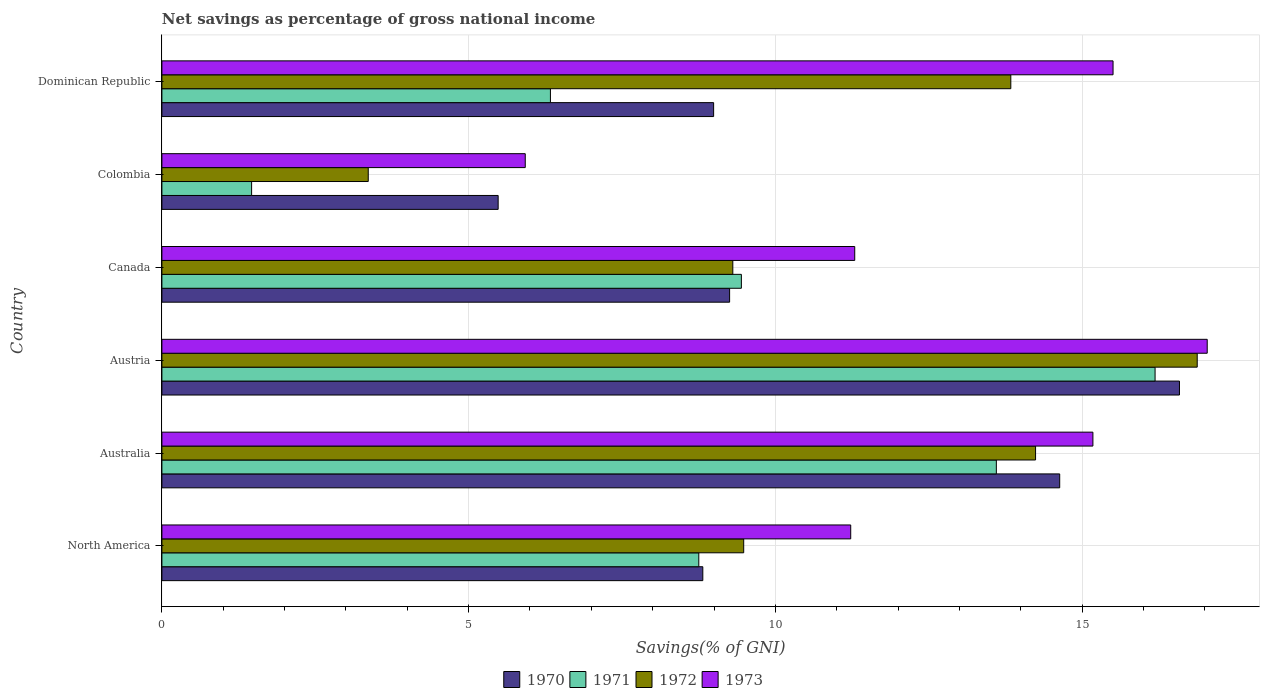Are the number of bars per tick equal to the number of legend labels?
Provide a short and direct response. Yes. How many bars are there on the 2nd tick from the top?
Your response must be concise. 4. What is the label of the 5th group of bars from the top?
Ensure brevity in your answer.  Australia. What is the total savings in 1970 in Dominican Republic?
Your response must be concise. 8.99. Across all countries, what is the maximum total savings in 1973?
Offer a terse response. 17.04. Across all countries, what is the minimum total savings in 1970?
Provide a succinct answer. 5.48. In which country was the total savings in 1972 maximum?
Offer a very short reply. Austria. In which country was the total savings in 1970 minimum?
Give a very brief answer. Colombia. What is the total total savings in 1970 in the graph?
Provide a succinct answer. 63.77. What is the difference between the total savings in 1972 in Colombia and that in Dominican Republic?
Provide a short and direct response. -10.47. What is the difference between the total savings in 1972 in Colombia and the total savings in 1973 in Australia?
Provide a short and direct response. -11.81. What is the average total savings in 1972 per country?
Provide a short and direct response. 11.19. What is the difference between the total savings in 1970 and total savings in 1971 in Austria?
Provide a short and direct response. 0.4. In how many countries, is the total savings in 1971 greater than 11 %?
Provide a succinct answer. 2. What is the ratio of the total savings in 1973 in Australia to that in North America?
Your answer should be very brief. 1.35. What is the difference between the highest and the second highest total savings in 1970?
Keep it short and to the point. 1.95. What is the difference between the highest and the lowest total savings in 1971?
Keep it short and to the point. 14.73. What does the 4th bar from the top in Canada represents?
Your answer should be compact. 1970. What does the 4th bar from the bottom in Canada represents?
Keep it short and to the point. 1973. What is the difference between two consecutive major ticks on the X-axis?
Give a very brief answer. 5. Are the values on the major ticks of X-axis written in scientific E-notation?
Offer a very short reply. No. Does the graph contain grids?
Provide a short and direct response. Yes. How many legend labels are there?
Ensure brevity in your answer.  4. What is the title of the graph?
Ensure brevity in your answer.  Net savings as percentage of gross national income. What is the label or title of the X-axis?
Offer a terse response. Savings(% of GNI). What is the label or title of the Y-axis?
Your answer should be very brief. Country. What is the Savings(% of GNI) of 1970 in North America?
Ensure brevity in your answer.  8.82. What is the Savings(% of GNI) in 1971 in North America?
Keep it short and to the point. 8.75. What is the Savings(% of GNI) in 1972 in North America?
Give a very brief answer. 9.48. What is the Savings(% of GNI) of 1973 in North America?
Keep it short and to the point. 11.23. What is the Savings(% of GNI) of 1970 in Australia?
Offer a very short reply. 14.63. What is the Savings(% of GNI) of 1971 in Australia?
Offer a terse response. 13.6. What is the Savings(% of GNI) of 1972 in Australia?
Make the answer very short. 14.24. What is the Savings(% of GNI) of 1973 in Australia?
Offer a terse response. 15.18. What is the Savings(% of GNI) of 1970 in Austria?
Provide a short and direct response. 16.59. What is the Savings(% of GNI) in 1971 in Austria?
Provide a short and direct response. 16.19. What is the Savings(% of GNI) in 1972 in Austria?
Your response must be concise. 16.88. What is the Savings(% of GNI) of 1973 in Austria?
Ensure brevity in your answer.  17.04. What is the Savings(% of GNI) in 1970 in Canada?
Make the answer very short. 9.25. What is the Savings(% of GNI) of 1971 in Canada?
Your answer should be very brief. 9.45. What is the Savings(% of GNI) in 1972 in Canada?
Offer a terse response. 9.31. What is the Savings(% of GNI) of 1973 in Canada?
Make the answer very short. 11.29. What is the Savings(% of GNI) of 1970 in Colombia?
Give a very brief answer. 5.48. What is the Savings(% of GNI) of 1971 in Colombia?
Provide a succinct answer. 1.46. What is the Savings(% of GNI) in 1972 in Colombia?
Your answer should be compact. 3.36. What is the Savings(% of GNI) of 1973 in Colombia?
Your answer should be very brief. 5.92. What is the Savings(% of GNI) in 1970 in Dominican Republic?
Offer a very short reply. 8.99. What is the Savings(% of GNI) of 1971 in Dominican Republic?
Your answer should be very brief. 6.33. What is the Savings(% of GNI) in 1972 in Dominican Republic?
Provide a short and direct response. 13.84. What is the Savings(% of GNI) in 1973 in Dominican Republic?
Keep it short and to the point. 15.5. Across all countries, what is the maximum Savings(% of GNI) of 1970?
Keep it short and to the point. 16.59. Across all countries, what is the maximum Savings(% of GNI) in 1971?
Your answer should be compact. 16.19. Across all countries, what is the maximum Savings(% of GNI) in 1972?
Your answer should be very brief. 16.88. Across all countries, what is the maximum Savings(% of GNI) of 1973?
Give a very brief answer. 17.04. Across all countries, what is the minimum Savings(% of GNI) of 1970?
Ensure brevity in your answer.  5.48. Across all countries, what is the minimum Savings(% of GNI) in 1971?
Give a very brief answer. 1.46. Across all countries, what is the minimum Savings(% of GNI) in 1972?
Your response must be concise. 3.36. Across all countries, what is the minimum Savings(% of GNI) of 1973?
Give a very brief answer. 5.92. What is the total Savings(% of GNI) in 1970 in the graph?
Provide a short and direct response. 63.77. What is the total Savings(% of GNI) of 1971 in the graph?
Offer a very short reply. 55.79. What is the total Savings(% of GNI) in 1972 in the graph?
Offer a terse response. 67.11. What is the total Savings(% of GNI) in 1973 in the graph?
Your answer should be compact. 76.17. What is the difference between the Savings(% of GNI) of 1970 in North America and that in Australia?
Your response must be concise. -5.82. What is the difference between the Savings(% of GNI) in 1971 in North America and that in Australia?
Keep it short and to the point. -4.85. What is the difference between the Savings(% of GNI) of 1972 in North America and that in Australia?
Give a very brief answer. -4.76. What is the difference between the Savings(% of GNI) in 1973 in North America and that in Australia?
Offer a very short reply. -3.95. What is the difference between the Savings(% of GNI) in 1970 in North America and that in Austria?
Make the answer very short. -7.77. What is the difference between the Savings(% of GNI) of 1971 in North America and that in Austria?
Your answer should be very brief. -7.44. What is the difference between the Savings(% of GNI) in 1972 in North America and that in Austria?
Keep it short and to the point. -7.39. What is the difference between the Savings(% of GNI) in 1973 in North America and that in Austria?
Ensure brevity in your answer.  -5.81. What is the difference between the Savings(% of GNI) of 1970 in North America and that in Canada?
Provide a succinct answer. -0.44. What is the difference between the Savings(% of GNI) in 1971 in North America and that in Canada?
Your answer should be compact. -0.69. What is the difference between the Savings(% of GNI) of 1972 in North America and that in Canada?
Give a very brief answer. 0.18. What is the difference between the Savings(% of GNI) of 1973 in North America and that in Canada?
Offer a terse response. -0.07. What is the difference between the Savings(% of GNI) in 1970 in North America and that in Colombia?
Provide a succinct answer. 3.34. What is the difference between the Savings(% of GNI) in 1971 in North America and that in Colombia?
Provide a succinct answer. 7.29. What is the difference between the Savings(% of GNI) in 1972 in North America and that in Colombia?
Provide a short and direct response. 6.12. What is the difference between the Savings(% of GNI) in 1973 in North America and that in Colombia?
Make the answer very short. 5.31. What is the difference between the Savings(% of GNI) in 1970 in North America and that in Dominican Republic?
Your answer should be compact. -0.18. What is the difference between the Savings(% of GNI) in 1971 in North America and that in Dominican Republic?
Your answer should be compact. 2.42. What is the difference between the Savings(% of GNI) of 1972 in North America and that in Dominican Republic?
Provide a succinct answer. -4.35. What is the difference between the Savings(% of GNI) in 1973 in North America and that in Dominican Republic?
Make the answer very short. -4.28. What is the difference between the Savings(% of GNI) of 1970 in Australia and that in Austria?
Your answer should be compact. -1.95. What is the difference between the Savings(% of GNI) of 1971 in Australia and that in Austria?
Provide a succinct answer. -2.59. What is the difference between the Savings(% of GNI) of 1972 in Australia and that in Austria?
Provide a short and direct response. -2.64. What is the difference between the Savings(% of GNI) in 1973 in Australia and that in Austria?
Your answer should be compact. -1.86. What is the difference between the Savings(% of GNI) in 1970 in Australia and that in Canada?
Make the answer very short. 5.38. What is the difference between the Savings(% of GNI) of 1971 in Australia and that in Canada?
Give a very brief answer. 4.16. What is the difference between the Savings(% of GNI) of 1972 in Australia and that in Canada?
Make the answer very short. 4.93. What is the difference between the Savings(% of GNI) of 1973 in Australia and that in Canada?
Offer a very short reply. 3.88. What is the difference between the Savings(% of GNI) in 1970 in Australia and that in Colombia?
Ensure brevity in your answer.  9.15. What is the difference between the Savings(% of GNI) of 1971 in Australia and that in Colombia?
Make the answer very short. 12.14. What is the difference between the Savings(% of GNI) in 1972 in Australia and that in Colombia?
Offer a terse response. 10.88. What is the difference between the Savings(% of GNI) in 1973 in Australia and that in Colombia?
Provide a short and direct response. 9.25. What is the difference between the Savings(% of GNI) of 1970 in Australia and that in Dominican Republic?
Make the answer very short. 5.64. What is the difference between the Savings(% of GNI) in 1971 in Australia and that in Dominican Republic?
Provide a succinct answer. 7.27. What is the difference between the Savings(% of GNI) of 1972 in Australia and that in Dominican Republic?
Give a very brief answer. 0.4. What is the difference between the Savings(% of GNI) of 1973 in Australia and that in Dominican Republic?
Offer a terse response. -0.33. What is the difference between the Savings(% of GNI) of 1970 in Austria and that in Canada?
Provide a succinct answer. 7.33. What is the difference between the Savings(% of GNI) in 1971 in Austria and that in Canada?
Give a very brief answer. 6.74. What is the difference between the Savings(% of GNI) in 1972 in Austria and that in Canada?
Give a very brief answer. 7.57. What is the difference between the Savings(% of GNI) in 1973 in Austria and that in Canada?
Your response must be concise. 5.75. What is the difference between the Savings(% of GNI) in 1970 in Austria and that in Colombia?
Keep it short and to the point. 11.11. What is the difference between the Savings(% of GNI) in 1971 in Austria and that in Colombia?
Ensure brevity in your answer.  14.73. What is the difference between the Savings(% of GNI) of 1972 in Austria and that in Colombia?
Ensure brevity in your answer.  13.51. What is the difference between the Savings(% of GNI) in 1973 in Austria and that in Colombia?
Offer a terse response. 11.12. What is the difference between the Savings(% of GNI) in 1970 in Austria and that in Dominican Republic?
Provide a succinct answer. 7.59. What is the difference between the Savings(% of GNI) of 1971 in Austria and that in Dominican Republic?
Offer a terse response. 9.86. What is the difference between the Savings(% of GNI) of 1972 in Austria and that in Dominican Republic?
Your response must be concise. 3.04. What is the difference between the Savings(% of GNI) of 1973 in Austria and that in Dominican Republic?
Provide a succinct answer. 1.54. What is the difference between the Savings(% of GNI) in 1970 in Canada and that in Colombia?
Keep it short and to the point. 3.77. What is the difference between the Savings(% of GNI) in 1971 in Canada and that in Colombia?
Offer a very short reply. 7.98. What is the difference between the Savings(% of GNI) of 1972 in Canada and that in Colombia?
Offer a very short reply. 5.94. What is the difference between the Savings(% of GNI) in 1973 in Canada and that in Colombia?
Keep it short and to the point. 5.37. What is the difference between the Savings(% of GNI) of 1970 in Canada and that in Dominican Republic?
Ensure brevity in your answer.  0.26. What is the difference between the Savings(% of GNI) in 1971 in Canada and that in Dominican Republic?
Make the answer very short. 3.11. What is the difference between the Savings(% of GNI) in 1972 in Canada and that in Dominican Republic?
Keep it short and to the point. -4.53. What is the difference between the Savings(% of GNI) of 1973 in Canada and that in Dominican Republic?
Keep it short and to the point. -4.21. What is the difference between the Savings(% of GNI) in 1970 in Colombia and that in Dominican Republic?
Your answer should be very brief. -3.51. What is the difference between the Savings(% of GNI) in 1971 in Colombia and that in Dominican Republic?
Provide a short and direct response. -4.87. What is the difference between the Savings(% of GNI) in 1972 in Colombia and that in Dominican Republic?
Offer a terse response. -10.47. What is the difference between the Savings(% of GNI) of 1973 in Colombia and that in Dominican Republic?
Provide a short and direct response. -9.58. What is the difference between the Savings(% of GNI) of 1970 in North America and the Savings(% of GNI) of 1971 in Australia?
Your response must be concise. -4.78. What is the difference between the Savings(% of GNI) in 1970 in North America and the Savings(% of GNI) in 1972 in Australia?
Keep it short and to the point. -5.42. What is the difference between the Savings(% of GNI) of 1970 in North America and the Savings(% of GNI) of 1973 in Australia?
Offer a terse response. -6.36. What is the difference between the Savings(% of GNI) in 1971 in North America and the Savings(% of GNI) in 1972 in Australia?
Make the answer very short. -5.49. What is the difference between the Savings(% of GNI) in 1971 in North America and the Savings(% of GNI) in 1973 in Australia?
Keep it short and to the point. -6.42. What is the difference between the Savings(% of GNI) of 1972 in North America and the Savings(% of GNI) of 1973 in Australia?
Ensure brevity in your answer.  -5.69. What is the difference between the Savings(% of GNI) of 1970 in North America and the Savings(% of GNI) of 1971 in Austria?
Give a very brief answer. -7.37. What is the difference between the Savings(% of GNI) of 1970 in North America and the Savings(% of GNI) of 1972 in Austria?
Keep it short and to the point. -8.06. What is the difference between the Savings(% of GNI) in 1970 in North America and the Savings(% of GNI) in 1973 in Austria?
Offer a terse response. -8.22. What is the difference between the Savings(% of GNI) of 1971 in North America and the Savings(% of GNI) of 1972 in Austria?
Keep it short and to the point. -8.12. What is the difference between the Savings(% of GNI) of 1971 in North America and the Savings(% of GNI) of 1973 in Austria?
Keep it short and to the point. -8.29. What is the difference between the Savings(% of GNI) of 1972 in North America and the Savings(% of GNI) of 1973 in Austria?
Offer a very short reply. -7.56. What is the difference between the Savings(% of GNI) of 1970 in North America and the Savings(% of GNI) of 1971 in Canada?
Your response must be concise. -0.63. What is the difference between the Savings(% of GNI) in 1970 in North America and the Savings(% of GNI) in 1972 in Canada?
Offer a very short reply. -0.49. What is the difference between the Savings(% of GNI) of 1970 in North America and the Savings(% of GNI) of 1973 in Canada?
Provide a succinct answer. -2.48. What is the difference between the Savings(% of GNI) in 1971 in North America and the Savings(% of GNI) in 1972 in Canada?
Keep it short and to the point. -0.55. What is the difference between the Savings(% of GNI) of 1971 in North America and the Savings(% of GNI) of 1973 in Canada?
Give a very brief answer. -2.54. What is the difference between the Savings(% of GNI) in 1972 in North America and the Savings(% of GNI) in 1973 in Canada?
Ensure brevity in your answer.  -1.81. What is the difference between the Savings(% of GNI) in 1970 in North America and the Savings(% of GNI) in 1971 in Colombia?
Provide a succinct answer. 7.36. What is the difference between the Savings(% of GNI) in 1970 in North America and the Savings(% of GNI) in 1972 in Colombia?
Keep it short and to the point. 5.45. What is the difference between the Savings(% of GNI) in 1970 in North America and the Savings(% of GNI) in 1973 in Colombia?
Make the answer very short. 2.89. What is the difference between the Savings(% of GNI) of 1971 in North America and the Savings(% of GNI) of 1972 in Colombia?
Provide a short and direct response. 5.39. What is the difference between the Savings(% of GNI) of 1971 in North America and the Savings(% of GNI) of 1973 in Colombia?
Keep it short and to the point. 2.83. What is the difference between the Savings(% of GNI) in 1972 in North America and the Savings(% of GNI) in 1973 in Colombia?
Your response must be concise. 3.56. What is the difference between the Savings(% of GNI) of 1970 in North America and the Savings(% of GNI) of 1971 in Dominican Republic?
Ensure brevity in your answer.  2.48. What is the difference between the Savings(% of GNI) in 1970 in North America and the Savings(% of GNI) in 1972 in Dominican Republic?
Offer a very short reply. -5.02. What is the difference between the Savings(% of GNI) in 1970 in North America and the Savings(% of GNI) in 1973 in Dominican Republic?
Your answer should be compact. -6.69. What is the difference between the Savings(% of GNI) in 1971 in North America and the Savings(% of GNI) in 1972 in Dominican Republic?
Provide a short and direct response. -5.09. What is the difference between the Savings(% of GNI) of 1971 in North America and the Savings(% of GNI) of 1973 in Dominican Republic?
Offer a terse response. -6.75. What is the difference between the Savings(% of GNI) in 1972 in North America and the Savings(% of GNI) in 1973 in Dominican Republic?
Your answer should be very brief. -6.02. What is the difference between the Savings(% of GNI) of 1970 in Australia and the Savings(% of GNI) of 1971 in Austria?
Your response must be concise. -1.55. What is the difference between the Savings(% of GNI) of 1970 in Australia and the Savings(% of GNI) of 1972 in Austria?
Offer a very short reply. -2.24. What is the difference between the Savings(% of GNI) in 1970 in Australia and the Savings(% of GNI) in 1973 in Austria?
Keep it short and to the point. -2.4. What is the difference between the Savings(% of GNI) in 1971 in Australia and the Savings(% of GNI) in 1972 in Austria?
Offer a terse response. -3.27. What is the difference between the Savings(% of GNI) in 1971 in Australia and the Savings(% of GNI) in 1973 in Austria?
Your answer should be very brief. -3.44. What is the difference between the Savings(% of GNI) in 1972 in Australia and the Savings(% of GNI) in 1973 in Austria?
Your response must be concise. -2.8. What is the difference between the Savings(% of GNI) of 1970 in Australia and the Savings(% of GNI) of 1971 in Canada?
Make the answer very short. 5.19. What is the difference between the Savings(% of GNI) in 1970 in Australia and the Savings(% of GNI) in 1972 in Canada?
Keep it short and to the point. 5.33. What is the difference between the Savings(% of GNI) of 1970 in Australia and the Savings(% of GNI) of 1973 in Canada?
Your answer should be compact. 3.34. What is the difference between the Savings(% of GNI) of 1971 in Australia and the Savings(% of GNI) of 1972 in Canada?
Give a very brief answer. 4.3. What is the difference between the Savings(% of GNI) in 1971 in Australia and the Savings(% of GNI) in 1973 in Canada?
Offer a terse response. 2.31. What is the difference between the Savings(% of GNI) of 1972 in Australia and the Savings(% of GNI) of 1973 in Canada?
Offer a terse response. 2.95. What is the difference between the Savings(% of GNI) in 1970 in Australia and the Savings(% of GNI) in 1971 in Colombia?
Provide a short and direct response. 13.17. What is the difference between the Savings(% of GNI) of 1970 in Australia and the Savings(% of GNI) of 1972 in Colombia?
Offer a terse response. 11.27. What is the difference between the Savings(% of GNI) in 1970 in Australia and the Savings(% of GNI) in 1973 in Colombia?
Make the answer very short. 8.71. What is the difference between the Savings(% of GNI) of 1971 in Australia and the Savings(% of GNI) of 1972 in Colombia?
Your response must be concise. 10.24. What is the difference between the Savings(% of GNI) of 1971 in Australia and the Savings(% of GNI) of 1973 in Colombia?
Provide a short and direct response. 7.68. What is the difference between the Savings(% of GNI) of 1972 in Australia and the Savings(% of GNI) of 1973 in Colombia?
Ensure brevity in your answer.  8.32. What is the difference between the Savings(% of GNI) of 1970 in Australia and the Savings(% of GNI) of 1971 in Dominican Republic?
Provide a succinct answer. 8.3. What is the difference between the Savings(% of GNI) in 1970 in Australia and the Savings(% of GNI) in 1972 in Dominican Republic?
Your response must be concise. 0.8. What is the difference between the Savings(% of GNI) in 1970 in Australia and the Savings(% of GNI) in 1973 in Dominican Republic?
Your answer should be very brief. -0.87. What is the difference between the Savings(% of GNI) in 1971 in Australia and the Savings(% of GNI) in 1972 in Dominican Republic?
Provide a succinct answer. -0.24. What is the difference between the Savings(% of GNI) of 1971 in Australia and the Savings(% of GNI) of 1973 in Dominican Republic?
Offer a terse response. -1.9. What is the difference between the Savings(% of GNI) of 1972 in Australia and the Savings(% of GNI) of 1973 in Dominican Republic?
Your answer should be compact. -1.26. What is the difference between the Savings(% of GNI) in 1970 in Austria and the Savings(% of GNI) in 1971 in Canada?
Your response must be concise. 7.14. What is the difference between the Savings(% of GNI) of 1970 in Austria and the Savings(% of GNI) of 1972 in Canada?
Your response must be concise. 7.28. What is the difference between the Savings(% of GNI) of 1970 in Austria and the Savings(% of GNI) of 1973 in Canada?
Make the answer very short. 5.29. What is the difference between the Savings(% of GNI) of 1971 in Austria and the Savings(% of GNI) of 1972 in Canada?
Your response must be concise. 6.88. What is the difference between the Savings(% of GNI) in 1971 in Austria and the Savings(% of GNI) in 1973 in Canada?
Make the answer very short. 4.9. What is the difference between the Savings(% of GNI) in 1972 in Austria and the Savings(% of GNI) in 1973 in Canada?
Keep it short and to the point. 5.58. What is the difference between the Savings(% of GNI) in 1970 in Austria and the Savings(% of GNI) in 1971 in Colombia?
Offer a terse response. 15.12. What is the difference between the Savings(% of GNI) of 1970 in Austria and the Savings(% of GNI) of 1972 in Colombia?
Provide a short and direct response. 13.22. What is the difference between the Savings(% of GNI) in 1970 in Austria and the Savings(% of GNI) in 1973 in Colombia?
Provide a succinct answer. 10.66. What is the difference between the Savings(% of GNI) in 1971 in Austria and the Savings(% of GNI) in 1972 in Colombia?
Your answer should be compact. 12.83. What is the difference between the Savings(% of GNI) of 1971 in Austria and the Savings(% of GNI) of 1973 in Colombia?
Ensure brevity in your answer.  10.27. What is the difference between the Savings(% of GNI) in 1972 in Austria and the Savings(% of GNI) in 1973 in Colombia?
Offer a terse response. 10.95. What is the difference between the Savings(% of GNI) in 1970 in Austria and the Savings(% of GNI) in 1971 in Dominican Republic?
Your answer should be very brief. 10.25. What is the difference between the Savings(% of GNI) of 1970 in Austria and the Savings(% of GNI) of 1972 in Dominican Republic?
Ensure brevity in your answer.  2.75. What is the difference between the Savings(% of GNI) in 1970 in Austria and the Savings(% of GNI) in 1973 in Dominican Republic?
Provide a succinct answer. 1.08. What is the difference between the Savings(% of GNI) of 1971 in Austria and the Savings(% of GNI) of 1972 in Dominican Republic?
Ensure brevity in your answer.  2.35. What is the difference between the Savings(% of GNI) in 1971 in Austria and the Savings(% of GNI) in 1973 in Dominican Republic?
Offer a very short reply. 0.69. What is the difference between the Savings(% of GNI) of 1972 in Austria and the Savings(% of GNI) of 1973 in Dominican Republic?
Ensure brevity in your answer.  1.37. What is the difference between the Savings(% of GNI) of 1970 in Canada and the Savings(% of GNI) of 1971 in Colombia?
Offer a very short reply. 7.79. What is the difference between the Savings(% of GNI) in 1970 in Canada and the Savings(% of GNI) in 1972 in Colombia?
Your answer should be compact. 5.89. What is the difference between the Savings(% of GNI) in 1970 in Canada and the Savings(% of GNI) in 1973 in Colombia?
Your response must be concise. 3.33. What is the difference between the Savings(% of GNI) in 1971 in Canada and the Savings(% of GNI) in 1972 in Colombia?
Make the answer very short. 6.08. What is the difference between the Savings(% of GNI) of 1971 in Canada and the Savings(% of GNI) of 1973 in Colombia?
Ensure brevity in your answer.  3.52. What is the difference between the Savings(% of GNI) in 1972 in Canada and the Savings(% of GNI) in 1973 in Colombia?
Your response must be concise. 3.38. What is the difference between the Savings(% of GNI) of 1970 in Canada and the Savings(% of GNI) of 1971 in Dominican Republic?
Keep it short and to the point. 2.92. What is the difference between the Savings(% of GNI) in 1970 in Canada and the Savings(% of GNI) in 1972 in Dominican Republic?
Keep it short and to the point. -4.58. What is the difference between the Savings(% of GNI) in 1970 in Canada and the Savings(% of GNI) in 1973 in Dominican Republic?
Offer a terse response. -6.25. What is the difference between the Savings(% of GNI) of 1971 in Canada and the Savings(% of GNI) of 1972 in Dominican Republic?
Offer a very short reply. -4.39. What is the difference between the Savings(% of GNI) of 1971 in Canada and the Savings(% of GNI) of 1973 in Dominican Republic?
Offer a very short reply. -6.06. What is the difference between the Savings(% of GNI) of 1972 in Canada and the Savings(% of GNI) of 1973 in Dominican Republic?
Offer a terse response. -6.2. What is the difference between the Savings(% of GNI) in 1970 in Colombia and the Savings(% of GNI) in 1971 in Dominican Republic?
Your answer should be compact. -0.85. What is the difference between the Savings(% of GNI) of 1970 in Colombia and the Savings(% of GNI) of 1972 in Dominican Republic?
Your answer should be compact. -8.36. What is the difference between the Savings(% of GNI) of 1970 in Colombia and the Savings(% of GNI) of 1973 in Dominican Republic?
Your answer should be compact. -10.02. What is the difference between the Savings(% of GNI) of 1971 in Colombia and the Savings(% of GNI) of 1972 in Dominican Republic?
Your answer should be compact. -12.38. What is the difference between the Savings(% of GNI) of 1971 in Colombia and the Savings(% of GNI) of 1973 in Dominican Republic?
Your answer should be compact. -14.04. What is the difference between the Savings(% of GNI) in 1972 in Colombia and the Savings(% of GNI) in 1973 in Dominican Republic?
Provide a short and direct response. -12.14. What is the average Savings(% of GNI) of 1970 per country?
Ensure brevity in your answer.  10.63. What is the average Savings(% of GNI) of 1971 per country?
Keep it short and to the point. 9.3. What is the average Savings(% of GNI) in 1972 per country?
Make the answer very short. 11.19. What is the average Savings(% of GNI) of 1973 per country?
Give a very brief answer. 12.69. What is the difference between the Savings(% of GNI) of 1970 and Savings(% of GNI) of 1971 in North America?
Your answer should be very brief. 0.07. What is the difference between the Savings(% of GNI) of 1970 and Savings(% of GNI) of 1972 in North America?
Ensure brevity in your answer.  -0.67. What is the difference between the Savings(% of GNI) in 1970 and Savings(% of GNI) in 1973 in North America?
Provide a succinct answer. -2.41. What is the difference between the Savings(% of GNI) of 1971 and Savings(% of GNI) of 1972 in North America?
Your answer should be compact. -0.73. What is the difference between the Savings(% of GNI) in 1971 and Savings(% of GNI) in 1973 in North America?
Your answer should be very brief. -2.48. What is the difference between the Savings(% of GNI) of 1972 and Savings(% of GNI) of 1973 in North America?
Your response must be concise. -1.74. What is the difference between the Savings(% of GNI) in 1970 and Savings(% of GNI) in 1971 in Australia?
Ensure brevity in your answer.  1.03. What is the difference between the Savings(% of GNI) in 1970 and Savings(% of GNI) in 1972 in Australia?
Offer a very short reply. 0.39. What is the difference between the Savings(% of GNI) in 1970 and Savings(% of GNI) in 1973 in Australia?
Provide a succinct answer. -0.54. What is the difference between the Savings(% of GNI) in 1971 and Savings(% of GNI) in 1972 in Australia?
Offer a terse response. -0.64. What is the difference between the Savings(% of GNI) in 1971 and Savings(% of GNI) in 1973 in Australia?
Offer a very short reply. -1.57. What is the difference between the Savings(% of GNI) of 1972 and Savings(% of GNI) of 1973 in Australia?
Your response must be concise. -0.93. What is the difference between the Savings(% of GNI) in 1970 and Savings(% of GNI) in 1971 in Austria?
Offer a terse response. 0.4. What is the difference between the Savings(% of GNI) in 1970 and Savings(% of GNI) in 1972 in Austria?
Offer a terse response. -0.29. What is the difference between the Savings(% of GNI) of 1970 and Savings(% of GNI) of 1973 in Austria?
Provide a short and direct response. -0.45. What is the difference between the Savings(% of GNI) in 1971 and Savings(% of GNI) in 1972 in Austria?
Your answer should be compact. -0.69. What is the difference between the Savings(% of GNI) of 1971 and Savings(% of GNI) of 1973 in Austria?
Keep it short and to the point. -0.85. What is the difference between the Savings(% of GNI) of 1972 and Savings(% of GNI) of 1973 in Austria?
Your response must be concise. -0.16. What is the difference between the Savings(% of GNI) in 1970 and Savings(% of GNI) in 1971 in Canada?
Offer a very short reply. -0.19. What is the difference between the Savings(% of GNI) of 1970 and Savings(% of GNI) of 1972 in Canada?
Offer a terse response. -0.05. What is the difference between the Savings(% of GNI) of 1970 and Savings(% of GNI) of 1973 in Canada?
Ensure brevity in your answer.  -2.04. What is the difference between the Savings(% of GNI) in 1971 and Savings(% of GNI) in 1972 in Canada?
Keep it short and to the point. 0.14. What is the difference between the Savings(% of GNI) in 1971 and Savings(% of GNI) in 1973 in Canada?
Keep it short and to the point. -1.85. What is the difference between the Savings(% of GNI) in 1972 and Savings(% of GNI) in 1973 in Canada?
Make the answer very short. -1.99. What is the difference between the Savings(% of GNI) in 1970 and Savings(% of GNI) in 1971 in Colombia?
Your answer should be compact. 4.02. What is the difference between the Savings(% of GNI) of 1970 and Savings(% of GNI) of 1972 in Colombia?
Give a very brief answer. 2.12. What is the difference between the Savings(% of GNI) of 1970 and Savings(% of GNI) of 1973 in Colombia?
Your response must be concise. -0.44. What is the difference between the Savings(% of GNI) of 1971 and Savings(% of GNI) of 1972 in Colombia?
Provide a succinct answer. -1.9. What is the difference between the Savings(% of GNI) in 1971 and Savings(% of GNI) in 1973 in Colombia?
Your answer should be very brief. -4.46. What is the difference between the Savings(% of GNI) in 1972 and Savings(% of GNI) in 1973 in Colombia?
Your answer should be compact. -2.56. What is the difference between the Savings(% of GNI) in 1970 and Savings(% of GNI) in 1971 in Dominican Republic?
Keep it short and to the point. 2.66. What is the difference between the Savings(% of GNI) in 1970 and Savings(% of GNI) in 1972 in Dominican Republic?
Your response must be concise. -4.84. What is the difference between the Savings(% of GNI) of 1970 and Savings(% of GNI) of 1973 in Dominican Republic?
Provide a short and direct response. -6.51. What is the difference between the Savings(% of GNI) of 1971 and Savings(% of GNI) of 1972 in Dominican Republic?
Your answer should be very brief. -7.5. What is the difference between the Savings(% of GNI) in 1971 and Savings(% of GNI) in 1973 in Dominican Republic?
Your answer should be compact. -9.17. What is the difference between the Savings(% of GNI) in 1972 and Savings(% of GNI) in 1973 in Dominican Republic?
Offer a very short reply. -1.67. What is the ratio of the Savings(% of GNI) of 1970 in North America to that in Australia?
Your answer should be very brief. 0.6. What is the ratio of the Savings(% of GNI) of 1971 in North America to that in Australia?
Provide a short and direct response. 0.64. What is the ratio of the Savings(% of GNI) of 1972 in North America to that in Australia?
Give a very brief answer. 0.67. What is the ratio of the Savings(% of GNI) in 1973 in North America to that in Australia?
Your answer should be compact. 0.74. What is the ratio of the Savings(% of GNI) of 1970 in North America to that in Austria?
Keep it short and to the point. 0.53. What is the ratio of the Savings(% of GNI) of 1971 in North America to that in Austria?
Provide a short and direct response. 0.54. What is the ratio of the Savings(% of GNI) of 1972 in North America to that in Austria?
Offer a terse response. 0.56. What is the ratio of the Savings(% of GNI) of 1973 in North America to that in Austria?
Provide a short and direct response. 0.66. What is the ratio of the Savings(% of GNI) in 1970 in North America to that in Canada?
Keep it short and to the point. 0.95. What is the ratio of the Savings(% of GNI) in 1971 in North America to that in Canada?
Your answer should be very brief. 0.93. What is the ratio of the Savings(% of GNI) of 1972 in North America to that in Canada?
Your answer should be very brief. 1.02. What is the ratio of the Savings(% of GNI) of 1973 in North America to that in Canada?
Offer a terse response. 0.99. What is the ratio of the Savings(% of GNI) of 1970 in North America to that in Colombia?
Offer a very short reply. 1.61. What is the ratio of the Savings(% of GNI) of 1971 in North America to that in Colombia?
Offer a very short reply. 5.98. What is the ratio of the Savings(% of GNI) in 1972 in North America to that in Colombia?
Make the answer very short. 2.82. What is the ratio of the Savings(% of GNI) of 1973 in North America to that in Colombia?
Keep it short and to the point. 1.9. What is the ratio of the Savings(% of GNI) of 1970 in North America to that in Dominican Republic?
Provide a short and direct response. 0.98. What is the ratio of the Savings(% of GNI) in 1971 in North America to that in Dominican Republic?
Provide a succinct answer. 1.38. What is the ratio of the Savings(% of GNI) in 1972 in North America to that in Dominican Republic?
Keep it short and to the point. 0.69. What is the ratio of the Savings(% of GNI) of 1973 in North America to that in Dominican Republic?
Your answer should be compact. 0.72. What is the ratio of the Savings(% of GNI) in 1970 in Australia to that in Austria?
Provide a short and direct response. 0.88. What is the ratio of the Savings(% of GNI) in 1971 in Australia to that in Austria?
Ensure brevity in your answer.  0.84. What is the ratio of the Savings(% of GNI) of 1972 in Australia to that in Austria?
Your answer should be compact. 0.84. What is the ratio of the Savings(% of GNI) in 1973 in Australia to that in Austria?
Give a very brief answer. 0.89. What is the ratio of the Savings(% of GNI) in 1970 in Australia to that in Canada?
Ensure brevity in your answer.  1.58. What is the ratio of the Savings(% of GNI) of 1971 in Australia to that in Canada?
Provide a succinct answer. 1.44. What is the ratio of the Savings(% of GNI) of 1972 in Australia to that in Canada?
Your answer should be very brief. 1.53. What is the ratio of the Savings(% of GNI) in 1973 in Australia to that in Canada?
Ensure brevity in your answer.  1.34. What is the ratio of the Savings(% of GNI) of 1970 in Australia to that in Colombia?
Give a very brief answer. 2.67. What is the ratio of the Savings(% of GNI) in 1971 in Australia to that in Colombia?
Your answer should be compact. 9.3. What is the ratio of the Savings(% of GNI) of 1972 in Australia to that in Colombia?
Make the answer very short. 4.23. What is the ratio of the Savings(% of GNI) in 1973 in Australia to that in Colombia?
Your response must be concise. 2.56. What is the ratio of the Savings(% of GNI) of 1970 in Australia to that in Dominican Republic?
Give a very brief answer. 1.63. What is the ratio of the Savings(% of GNI) in 1971 in Australia to that in Dominican Republic?
Your answer should be very brief. 2.15. What is the ratio of the Savings(% of GNI) in 1972 in Australia to that in Dominican Republic?
Make the answer very short. 1.03. What is the ratio of the Savings(% of GNI) of 1973 in Australia to that in Dominican Republic?
Provide a succinct answer. 0.98. What is the ratio of the Savings(% of GNI) of 1970 in Austria to that in Canada?
Keep it short and to the point. 1.79. What is the ratio of the Savings(% of GNI) of 1971 in Austria to that in Canada?
Your response must be concise. 1.71. What is the ratio of the Savings(% of GNI) in 1972 in Austria to that in Canada?
Your response must be concise. 1.81. What is the ratio of the Savings(% of GNI) in 1973 in Austria to that in Canada?
Offer a very short reply. 1.51. What is the ratio of the Savings(% of GNI) in 1970 in Austria to that in Colombia?
Give a very brief answer. 3.03. What is the ratio of the Savings(% of GNI) of 1971 in Austria to that in Colombia?
Give a very brief answer. 11.07. What is the ratio of the Savings(% of GNI) of 1972 in Austria to that in Colombia?
Keep it short and to the point. 5.02. What is the ratio of the Savings(% of GNI) in 1973 in Austria to that in Colombia?
Give a very brief answer. 2.88. What is the ratio of the Savings(% of GNI) of 1970 in Austria to that in Dominican Republic?
Ensure brevity in your answer.  1.84. What is the ratio of the Savings(% of GNI) in 1971 in Austria to that in Dominican Republic?
Provide a short and direct response. 2.56. What is the ratio of the Savings(% of GNI) of 1972 in Austria to that in Dominican Republic?
Your answer should be compact. 1.22. What is the ratio of the Savings(% of GNI) of 1973 in Austria to that in Dominican Republic?
Your answer should be compact. 1.1. What is the ratio of the Savings(% of GNI) in 1970 in Canada to that in Colombia?
Give a very brief answer. 1.69. What is the ratio of the Savings(% of GNI) in 1971 in Canada to that in Colombia?
Make the answer very short. 6.46. What is the ratio of the Savings(% of GNI) in 1972 in Canada to that in Colombia?
Provide a succinct answer. 2.77. What is the ratio of the Savings(% of GNI) in 1973 in Canada to that in Colombia?
Your answer should be compact. 1.91. What is the ratio of the Savings(% of GNI) in 1971 in Canada to that in Dominican Republic?
Provide a succinct answer. 1.49. What is the ratio of the Savings(% of GNI) of 1972 in Canada to that in Dominican Republic?
Offer a very short reply. 0.67. What is the ratio of the Savings(% of GNI) in 1973 in Canada to that in Dominican Republic?
Give a very brief answer. 0.73. What is the ratio of the Savings(% of GNI) in 1970 in Colombia to that in Dominican Republic?
Provide a short and direct response. 0.61. What is the ratio of the Savings(% of GNI) in 1971 in Colombia to that in Dominican Republic?
Offer a very short reply. 0.23. What is the ratio of the Savings(% of GNI) of 1972 in Colombia to that in Dominican Republic?
Your response must be concise. 0.24. What is the ratio of the Savings(% of GNI) in 1973 in Colombia to that in Dominican Republic?
Your response must be concise. 0.38. What is the difference between the highest and the second highest Savings(% of GNI) of 1970?
Provide a succinct answer. 1.95. What is the difference between the highest and the second highest Savings(% of GNI) of 1971?
Your response must be concise. 2.59. What is the difference between the highest and the second highest Savings(% of GNI) in 1972?
Provide a short and direct response. 2.64. What is the difference between the highest and the second highest Savings(% of GNI) in 1973?
Offer a terse response. 1.54. What is the difference between the highest and the lowest Savings(% of GNI) in 1970?
Offer a terse response. 11.11. What is the difference between the highest and the lowest Savings(% of GNI) in 1971?
Provide a succinct answer. 14.73. What is the difference between the highest and the lowest Savings(% of GNI) of 1972?
Keep it short and to the point. 13.51. What is the difference between the highest and the lowest Savings(% of GNI) of 1973?
Keep it short and to the point. 11.12. 